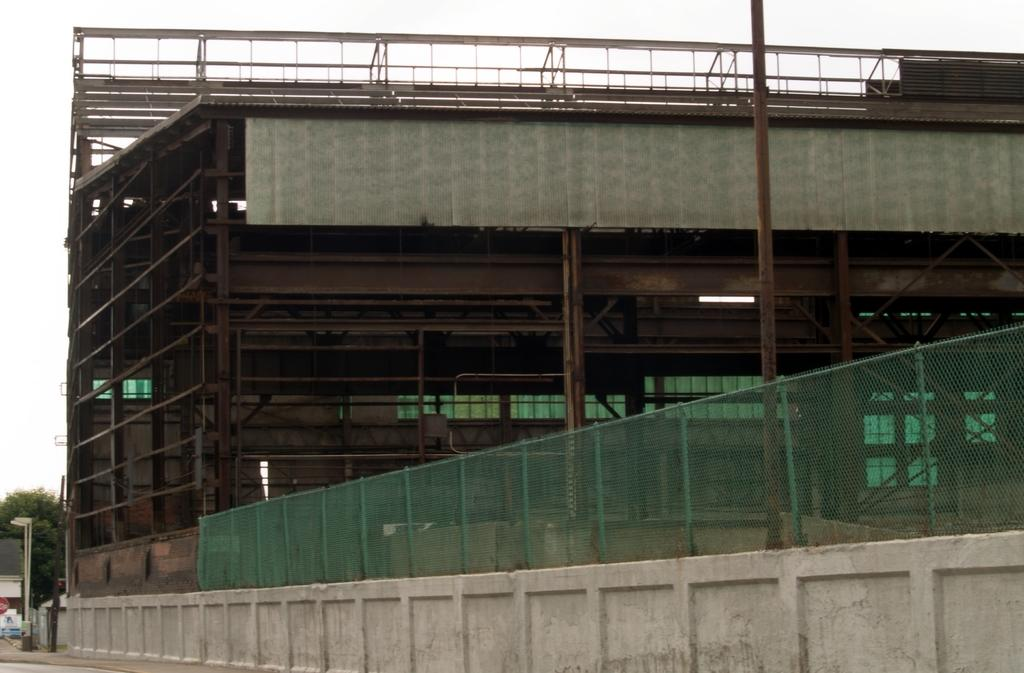What color is the curtain that is blocking the power in the image? There is no image provided, and therefore no curtain or power to be blocked can be observed. 